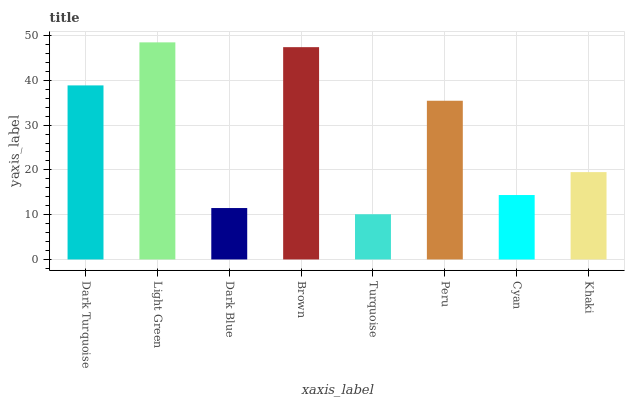Is Turquoise the minimum?
Answer yes or no. Yes. Is Light Green the maximum?
Answer yes or no. Yes. Is Dark Blue the minimum?
Answer yes or no. No. Is Dark Blue the maximum?
Answer yes or no. No. Is Light Green greater than Dark Blue?
Answer yes or no. Yes. Is Dark Blue less than Light Green?
Answer yes or no. Yes. Is Dark Blue greater than Light Green?
Answer yes or no. No. Is Light Green less than Dark Blue?
Answer yes or no. No. Is Peru the high median?
Answer yes or no. Yes. Is Khaki the low median?
Answer yes or no. Yes. Is Brown the high median?
Answer yes or no. No. Is Cyan the low median?
Answer yes or no. No. 